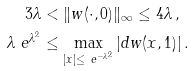<formula> <loc_0><loc_0><loc_500><loc_500>3 \lambda & < \| w ( \cdot , 0 ) \| _ { \infty } \leq 4 \lambda \, , \\ \lambda \ e ^ { \lambda ^ { 2 } } & \leq \max _ { | x | \leq \ e ^ { - \lambda ^ { 2 } } } | d w ( x , 1 ) | \, .</formula> 